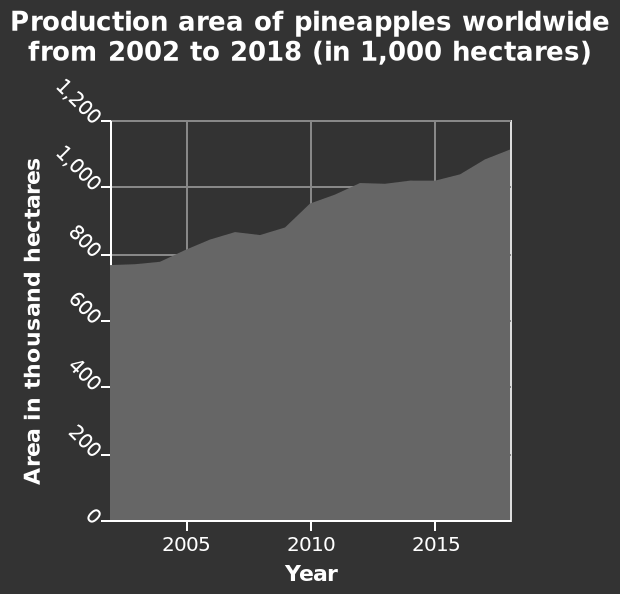<image>
What happened to the production area in 2015?  The production area increased in 2015. How did the area change in 2015?  The area now is larger compared to before. What is the title/figure of the diagram?  The title/figure of the diagram is "Production area of pineapples worldwide from 2002 to 2018 (in 1,000 hectares)". What is the range of years shown in the diagram? The range of years shown in the diagram is from 2002 to 2018. What is the labeled unit on the y-axis?  The labeled unit on the y-axis is "Area in thousand hectares". When did the increase in the area occur?  The increase in the area happened in 2015. 